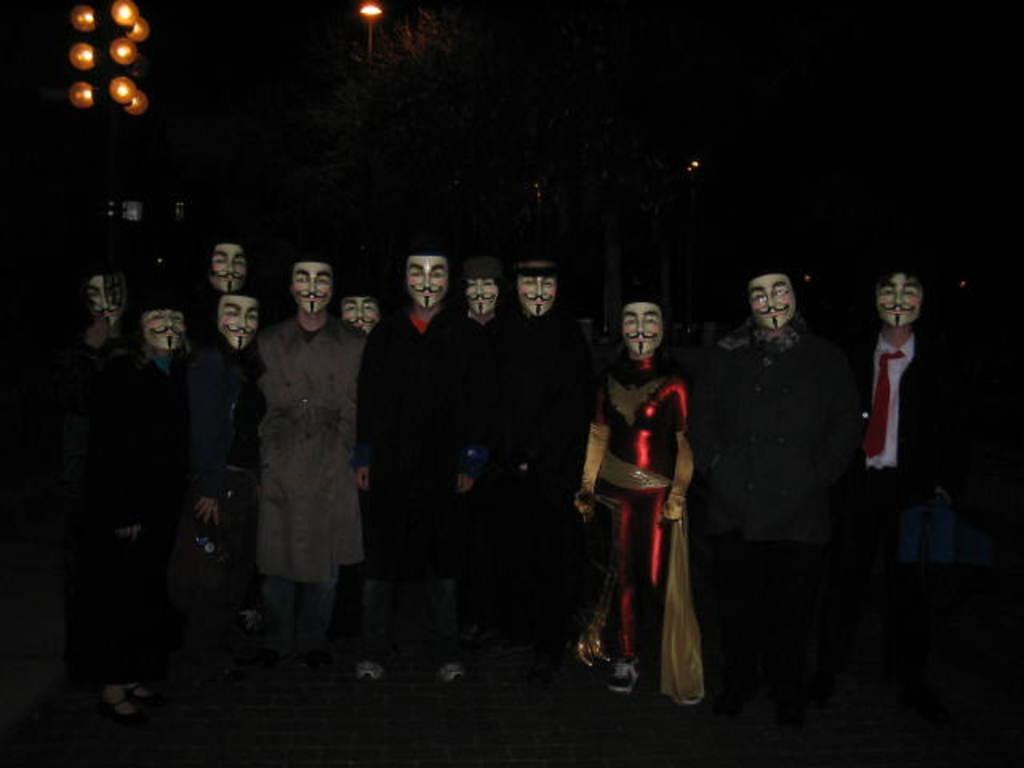Please provide a concise description of this image. In this image, we can see a group of people wearing face masks and standing on the path. In the background, we can see the dark view, trees, lights and few objects. 